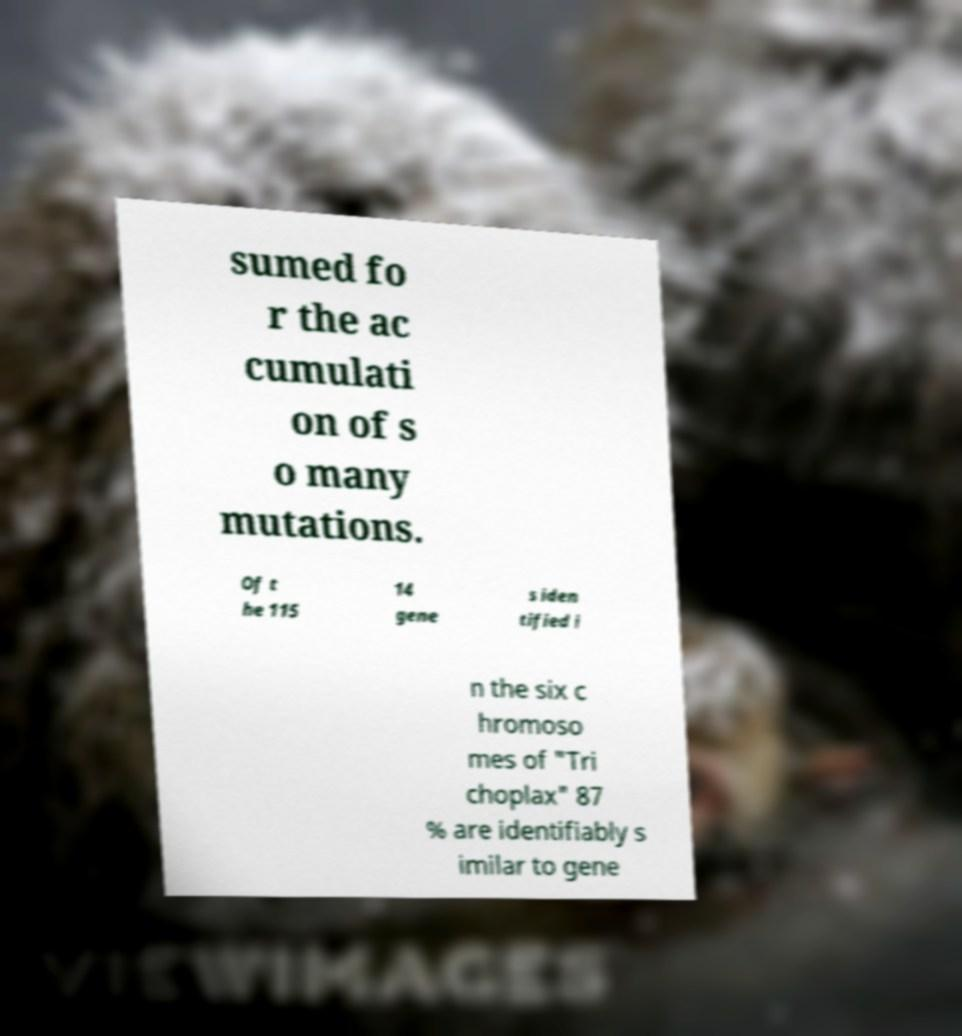There's text embedded in this image that I need extracted. Can you transcribe it verbatim? sumed fo r the ac cumulati on of s o many mutations. Of t he 115 14 gene s iden tified i n the six c hromoso mes of "Tri choplax" 87 % are identifiably s imilar to gene 